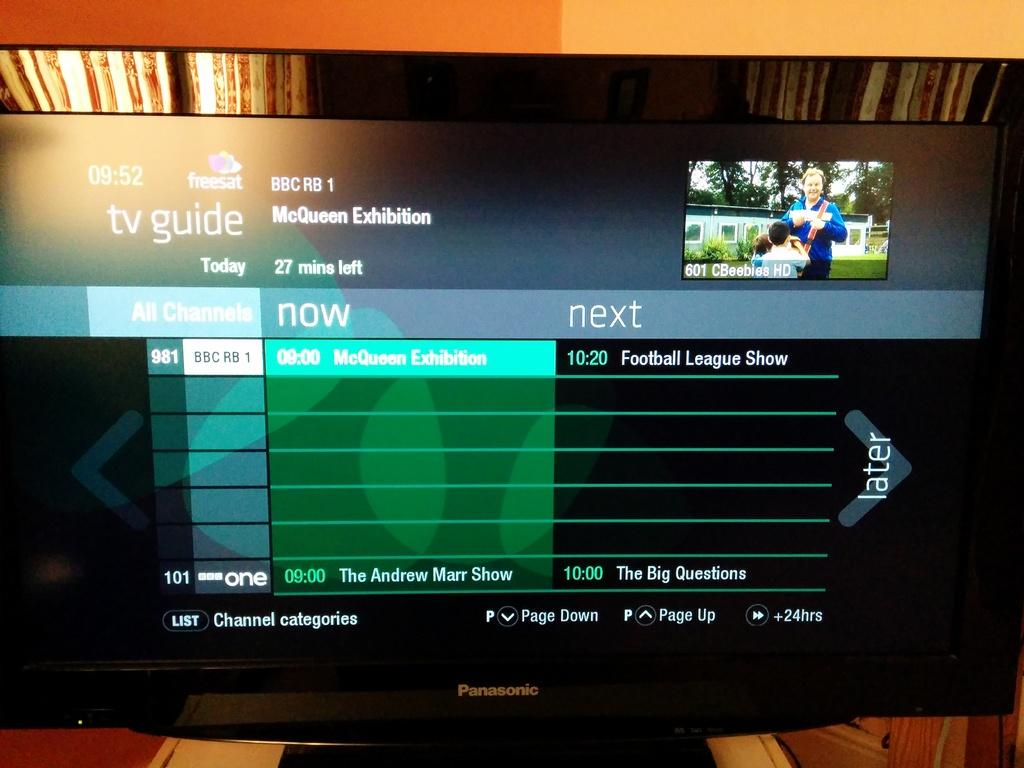<image>
Present a compact description of the photo's key features. A flat screen that says Panasonic on the front is showing the TV guide. 